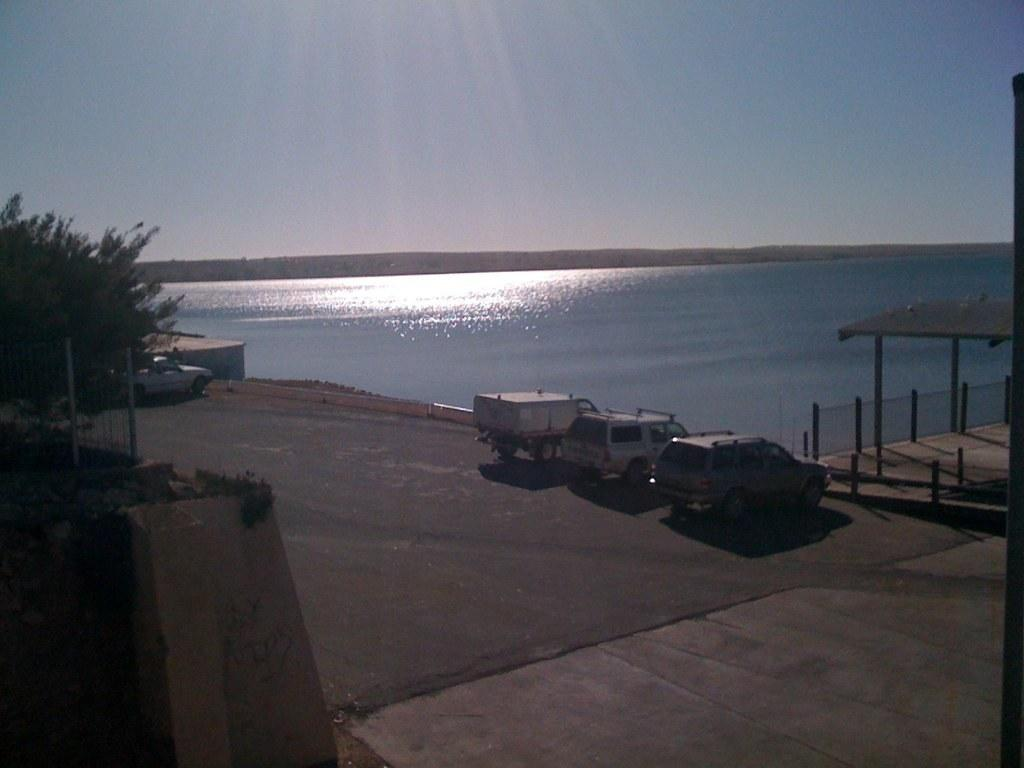What can be seen in the center of the image? There are cars on the road in the center of the image. What type of vegetation is on the left side of the image? There are trees on the left side of the image. What structure is located on the right side of the image? There is a shelter on the right side of the image. What is visible in the background of the image? There is water visible in the background of the image. Can you hear the church bells ringing in the image? There is no church or bells present in the image, so it is not possible to hear any church bells ringing. What type of crate is being used to transport the water in the image? There is no crate present in the image, and the water is visible in the background, not being transported. 